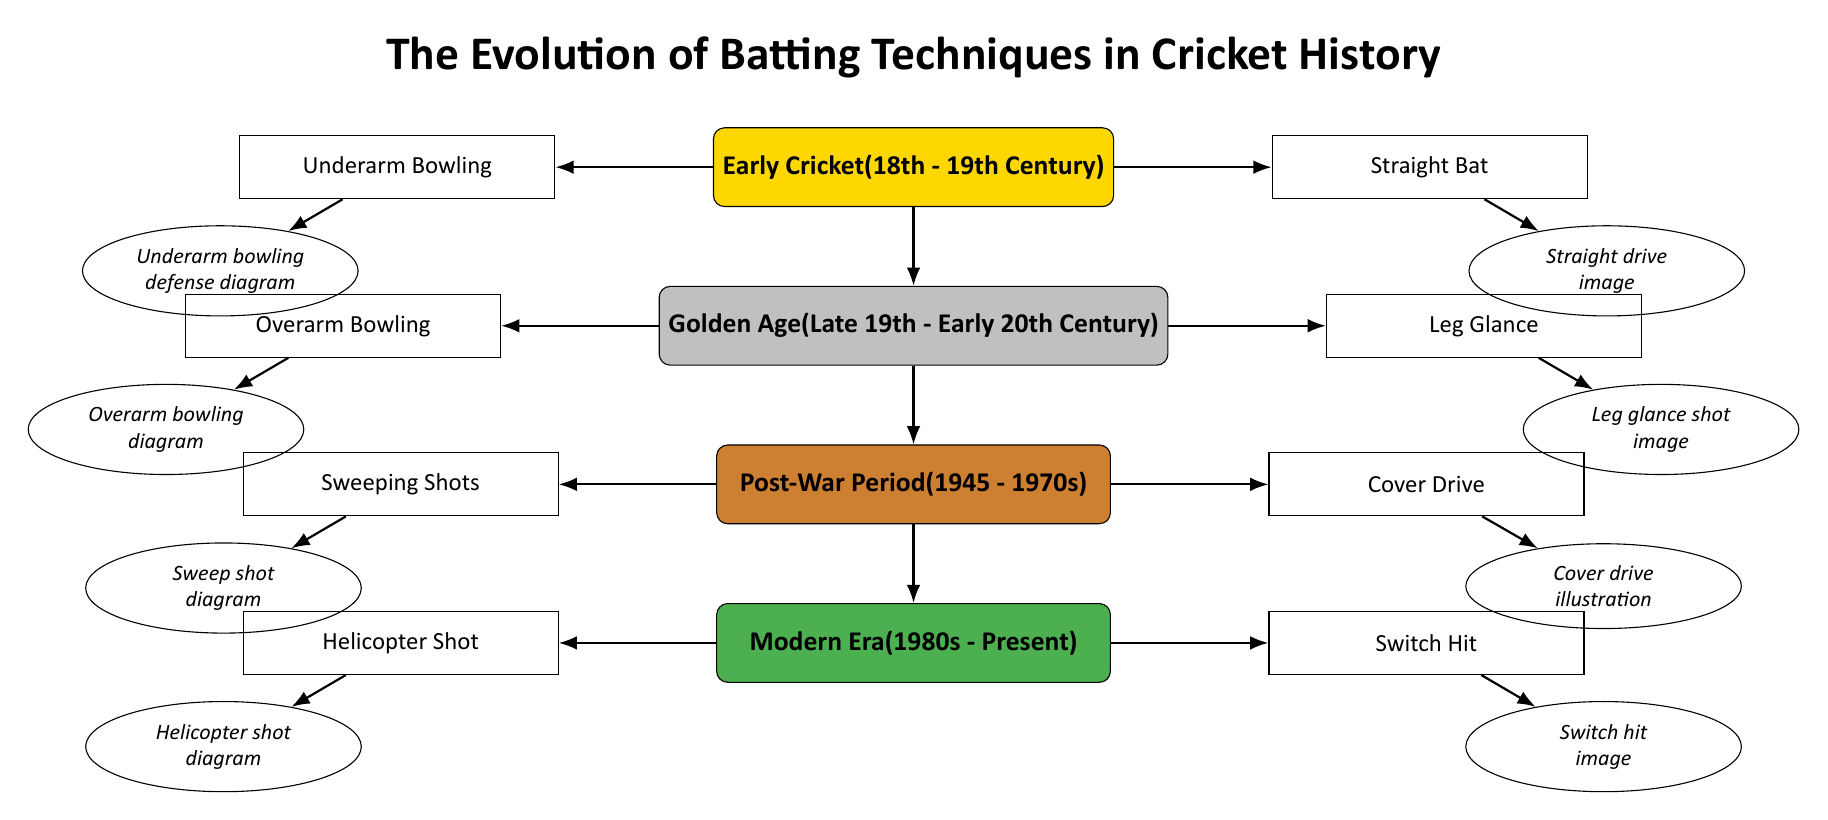What is the first era of batting techniques shown in the diagram? The diagram lists the batting techniques beginning with "Early Cricket (18th - 19th Century)" at the top, indicating it as the first era.
Answer: Early Cricket (18th - 19th Century) How many batting techniques are illustrated in the "Post-War Period"? In the "Post-War Period (1945 - 1970s)" section, there are two techniques shown: "Sweeping Shots" and "Cover Drive," which indicates the total count is two.
Answer: 2 What is the technique illustrated on the left side of the "Modern Era"? The technique on the left side of the "Modern Era (1980s - Present)" is "Helicopter Shot," shown as the first technique in that era.
Answer: Helicopter Shot Which era introduces the technique of "Leg Glance"? The technique "Leg Glance" is introduced in the "Golden Age (Late 19th - Early 20th Century)" section, where it's noted as one of the techniques for that era.
Answer: Golden Age (Late 19th - Early 20th Century) What is the relationship between the "Overarm Bowling" technique and its illustration? The diagram shows an arrow from the "Overarm Bowling" technique (left of the "Golden Age") directing to its corresponding illustration, which indicates it is associated with each other. This means the illustration visually represents the technique's concept.
Answer: Overarm Bowling and its illustration are linked Which technique is depicted alongside the "Straight Bat" in the early cricket era? The "Straight Bat," depicted on the right side of the "Early Cricket" era, is paired with the "Underarm Bowling" technique on the left, showing their simultaneous representation during that period.
Answer: Underarm Bowling In which era does the "Switch Hit" technique first appear? The "Switch Hit" technique is illustrated in the "Modern Era (1980s - Present)," established as part of the advancements in batting techniques during that timeframe.
Answer: Modern Era (1980s - Present) What technique evolved into the "Cover Drive" during the "Post-War Period"? The "Cover Drive" in the "Post-War Period (1945 - 1970s)" stands independently as a distinct technique, without a direct predecessor mentioned in the diagram, indicating its unique development during that time.
Answer: Cover Drive 